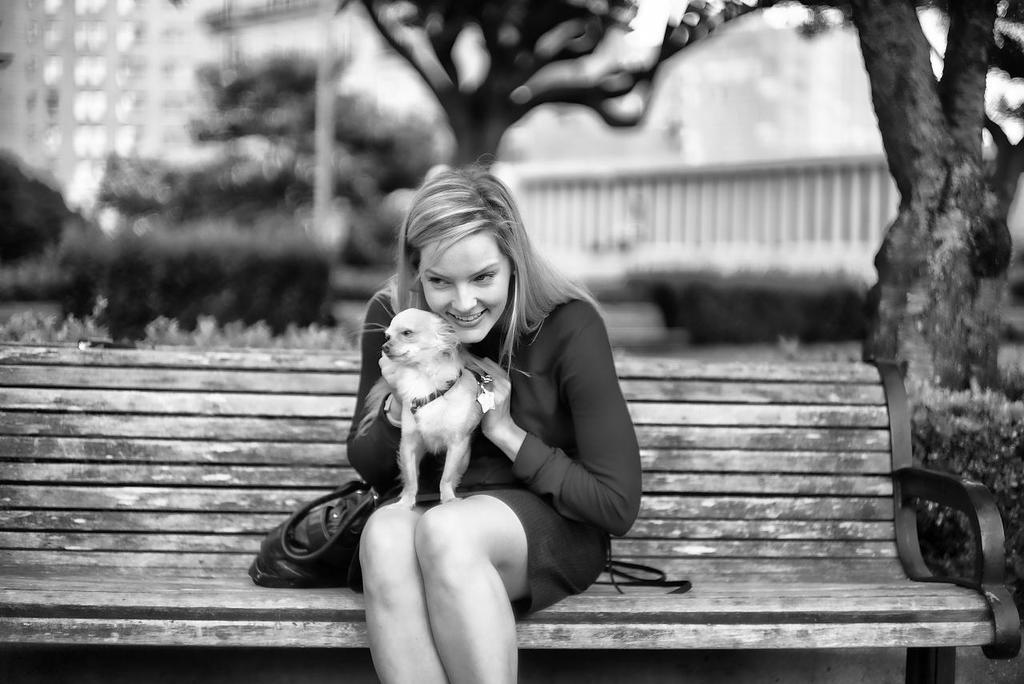What is the main subject of the image? There is a lady person in the image. What is the lady person wearing? The lady person is wearing a black dress. What is the lady person doing in the image? The lady person is sitting on a bench and catching a puppy. What can be seen in the background of the image? There are trees and buildings in the background of the image. What type of lunch is the lady person eating in the image? There is no lunch present in the image; the lady person is catching a puppy. What is the color of the ground in the image? The provided facts do not mention the color of the ground, so it cannot be determined from the image. 